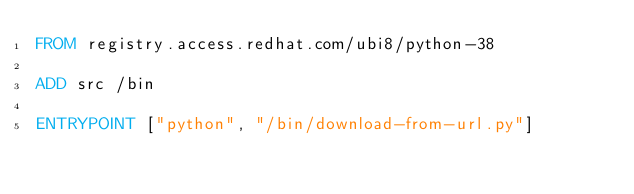Convert code to text. <code><loc_0><loc_0><loc_500><loc_500><_Dockerfile_>FROM registry.access.redhat.com/ubi8/python-38

ADD src /bin

ENTRYPOINT ["python", "/bin/download-from-url.py"]
</code> 